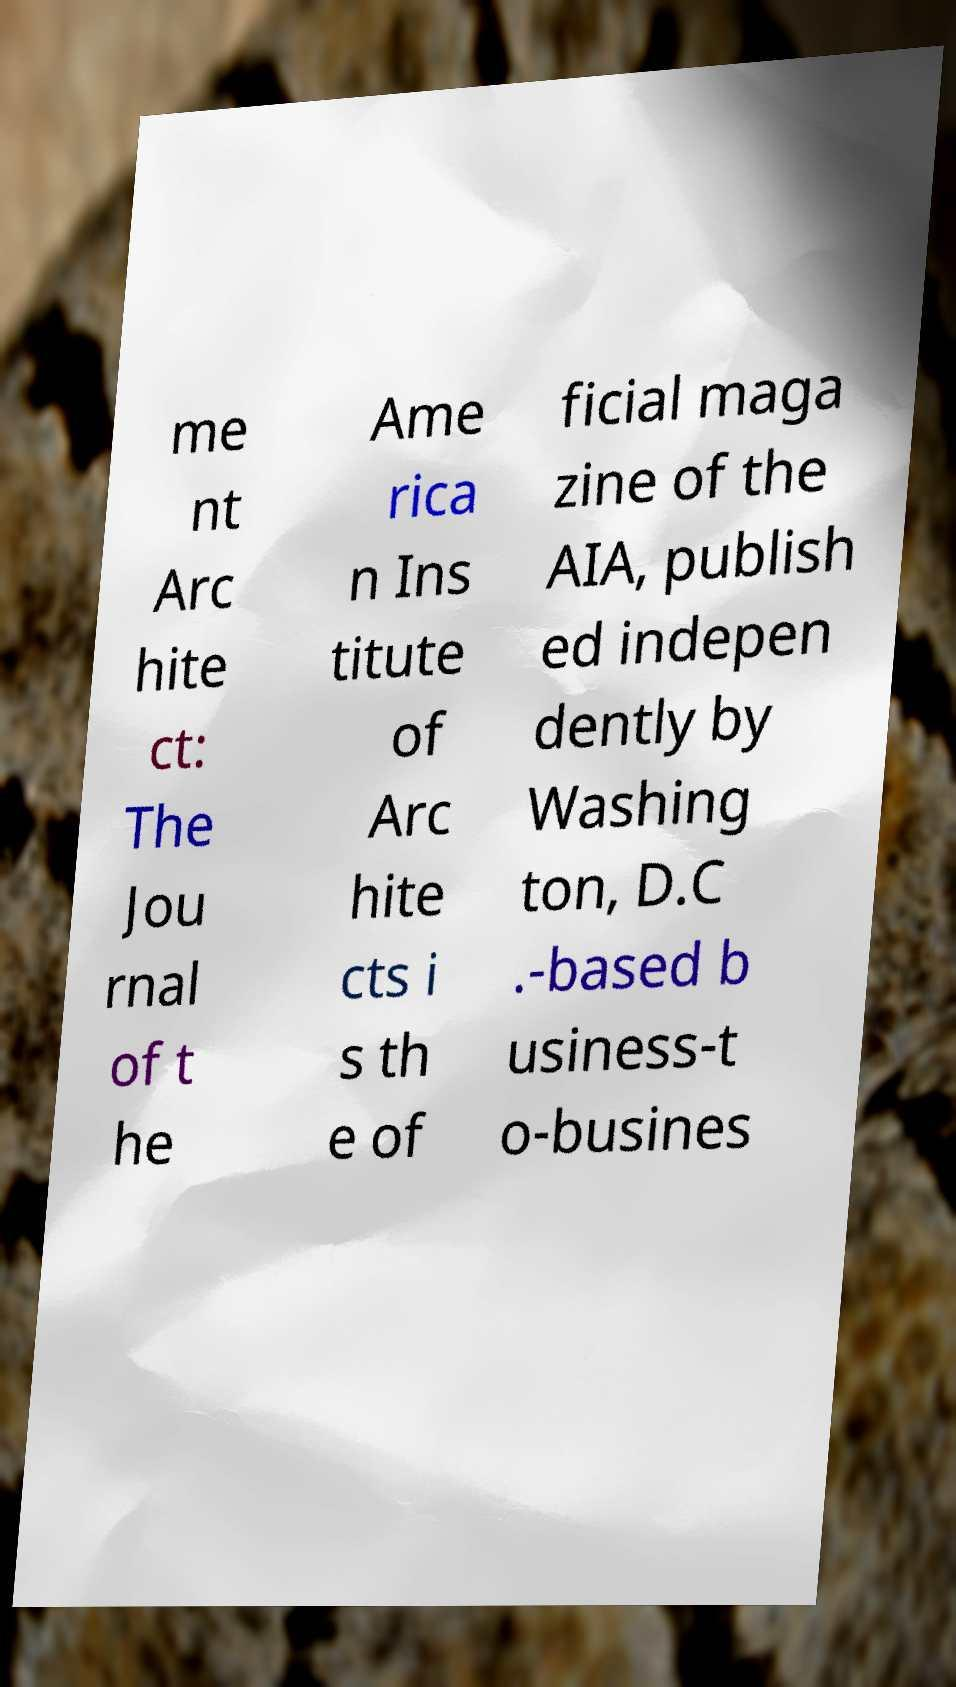Please read and relay the text visible in this image. What does it say? me nt Arc hite ct: The Jou rnal of t he Ame rica n Ins titute of Arc hite cts i s th e of ficial maga zine of the AIA, publish ed indepen dently by Washing ton, D.C .-based b usiness-t o-busines 